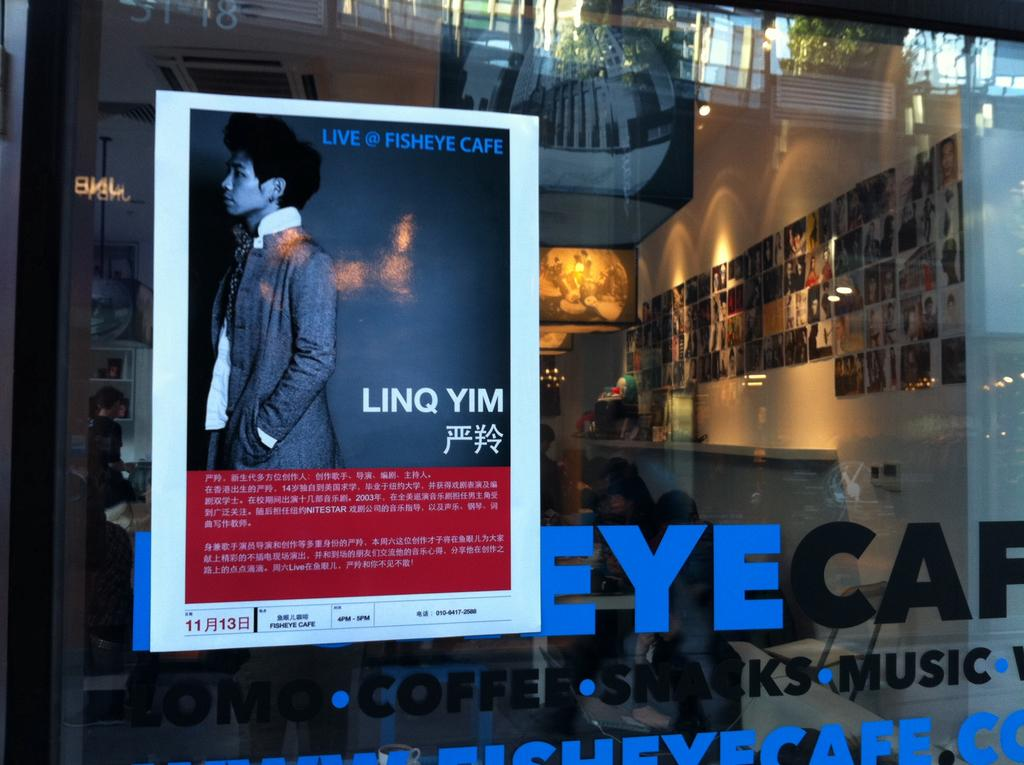<image>
Write a terse but informative summary of the picture. Linq Yim is live @ Fisheye Cafe, and it has Coffee, Snacks, and Music. 